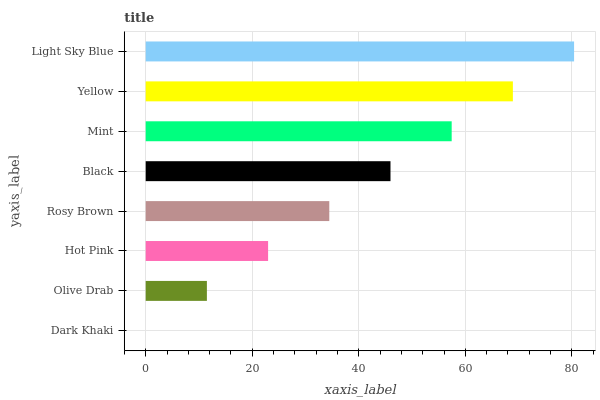Is Dark Khaki the minimum?
Answer yes or no. Yes. Is Light Sky Blue the maximum?
Answer yes or no. Yes. Is Olive Drab the minimum?
Answer yes or no. No. Is Olive Drab the maximum?
Answer yes or no. No. Is Olive Drab greater than Dark Khaki?
Answer yes or no. Yes. Is Dark Khaki less than Olive Drab?
Answer yes or no. Yes. Is Dark Khaki greater than Olive Drab?
Answer yes or no. No. Is Olive Drab less than Dark Khaki?
Answer yes or no. No. Is Black the high median?
Answer yes or no. Yes. Is Rosy Brown the low median?
Answer yes or no. Yes. Is Olive Drab the high median?
Answer yes or no. No. Is Black the low median?
Answer yes or no. No. 